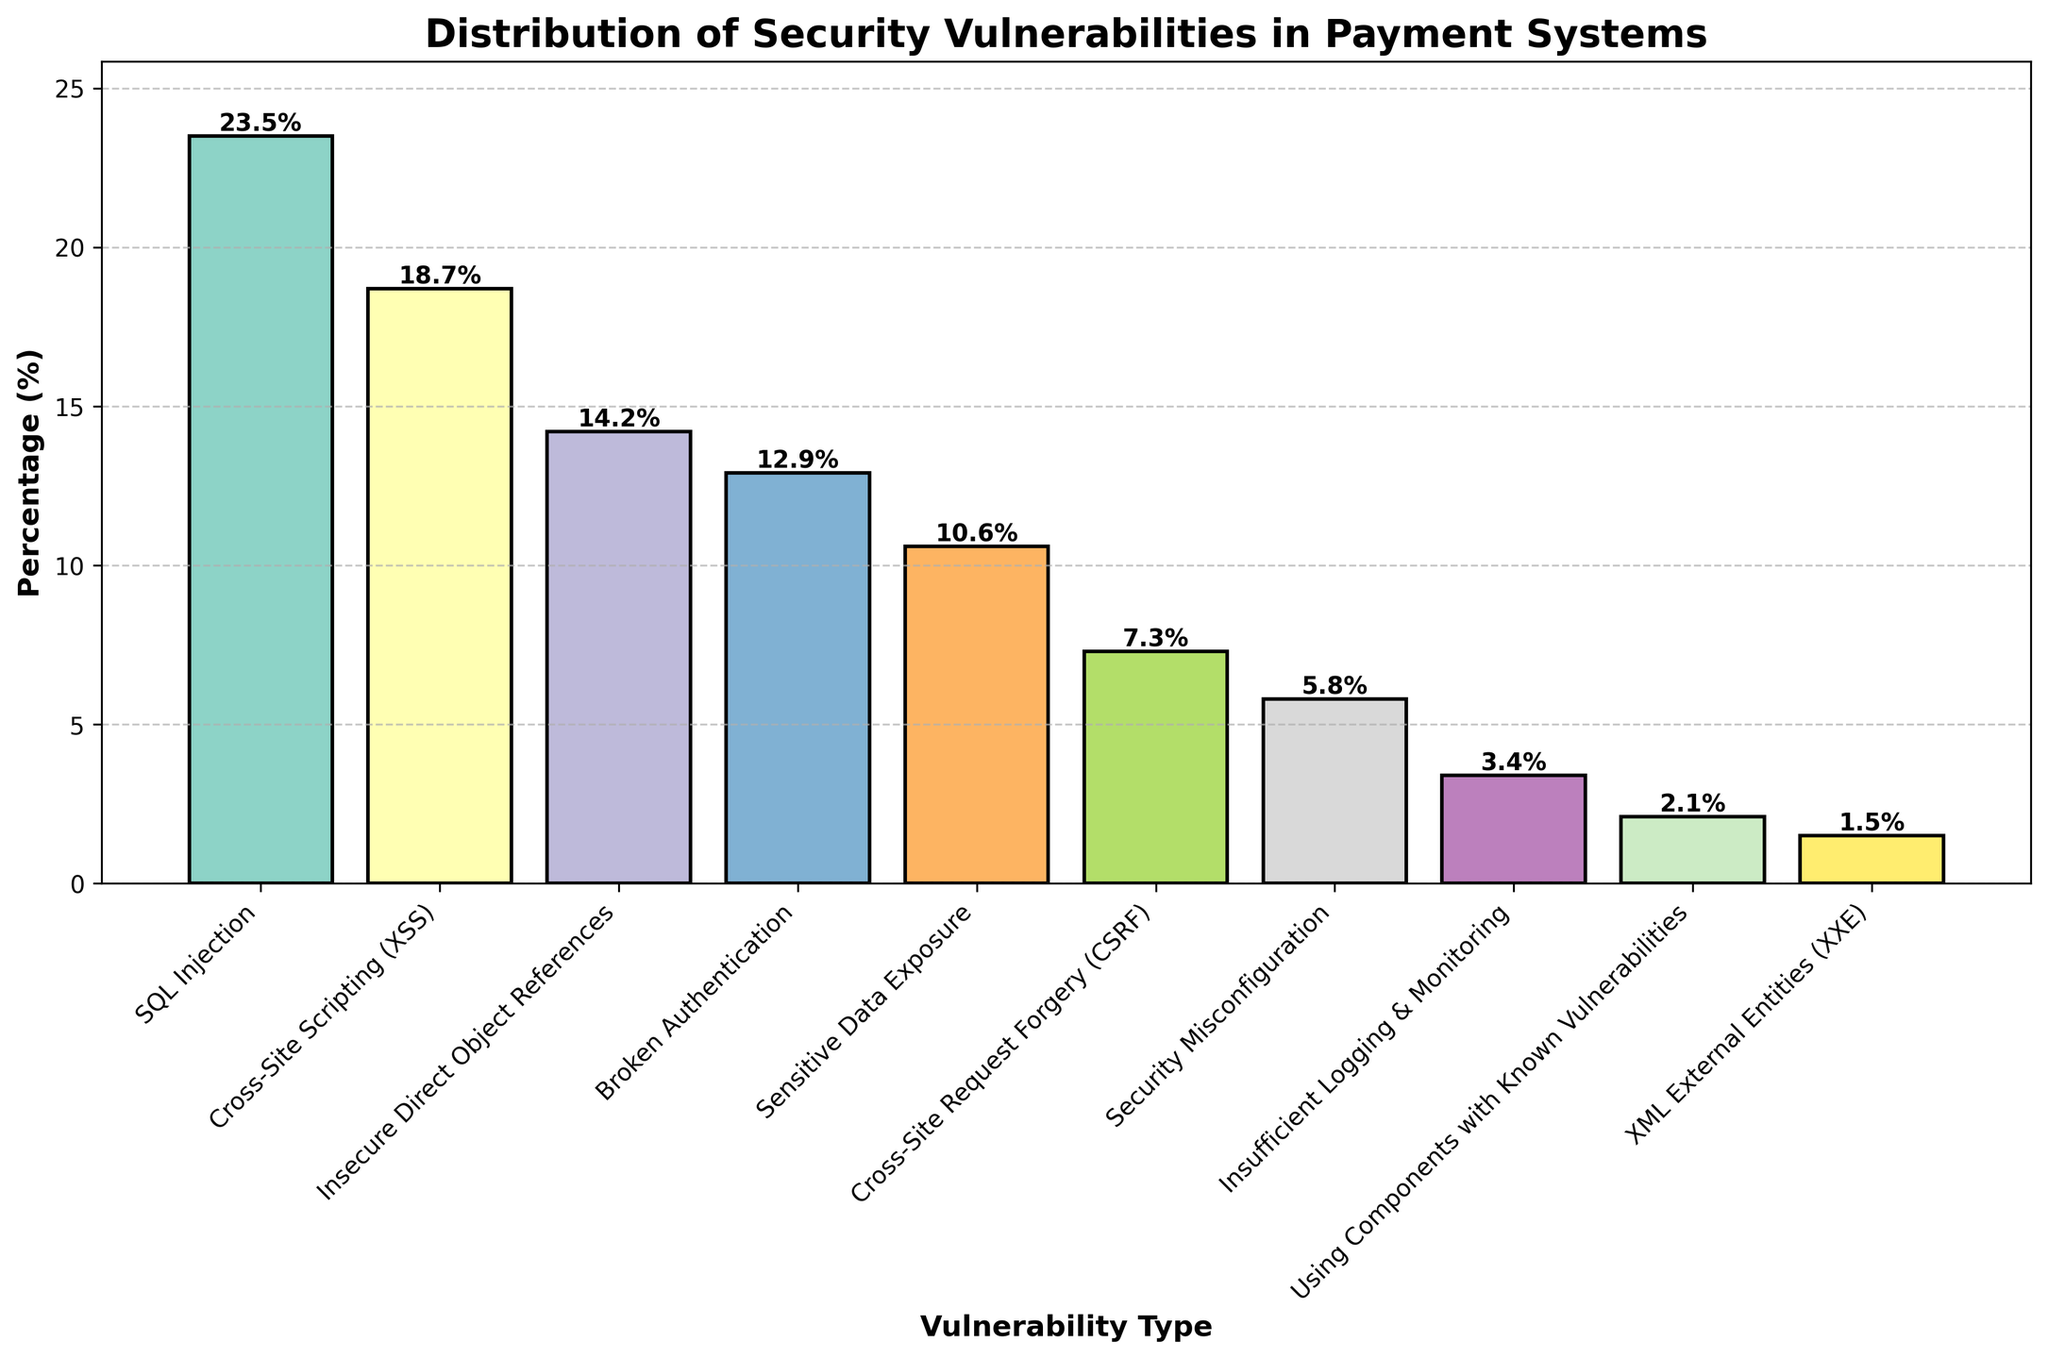Which type of security vulnerability is the most common in payment systems? The bar chart's title is "Distribution of Security Vulnerabilities in Payment Systems." The tallest bar represents SQL Injection, which has the highest percentage.
Answer: SQL Injection How does the percentage of Cross-Site Scripting (XSS) compare to Broken Authentication? Cross-Site Scripting (XSS) is at 18.7%, while Broken Authentication is at 12.9%. Comparing these two percentages directly, XSS is higher.
Answer: XSS is higher What is the combined percentage of Insecure Direct Object References and Sensitive Data Exposure? Insecure Direct Object References are 14.2%, and Sensitive Data Exposure is 10.6%. Adding these two percentages together: 14.2 + 10.6 = 24.8%.
Answer: 24.8% Does Cross-Site Request Forgery (CSRF) or Security Misconfiguration have a higher percentage? Cross-Site Request Forgery (CSRF) has a percentage of 7.3%, whereas Security Misconfiguration has a lower percentage of 5.8%.
Answer: CSRF is higher What's the difference in percentage between SQL Injection and Using Components with Known Vulnerabilities? SQL Injection is 23.5%, and Using Components with Known Vulnerabilities is 2.1%. Subtracting the two: 23.5 - 2.1 = 21.4%.
Answer: 21.4% What is the average percentage of all listed security vulnerabilities? Summing all the percentages: 23.5 + 18.7 + 14.2 + 12.9 + 10.6 + 7.3 + 5.8 + 3.4 + 2.1 + 1.5 = 100. The number of types is 10. So, the average is 100 / 10 = 10.0%.
Answer: 10.0% Among the listed types, which has the lowest percentage? By observing the shortest bar on the chart, XML External Entities (XXE) has the lowest percentage at 1.5%.
Answer: XML External Entities (XXE) What is the sum of the percentages for Cross-Site Scripting (XSS), Insecure Direct Object References, and Security Misconfiguration? XSS is 18.7%, Insecure Direct Object References is 14.2%, and Security Misconfiguration is 5.8%. Adding these together: 18.7 + 14.2 + 5.8 = 38.7%.
Answer: 38.7% Which has a higher combined percentage: Broken Authentication and Sensitive Data Exposure or Cross-Site Request Forgery (CSRF) and Security Misconfiguration? Broken Authentication is 12.9% and Sensitive Data Exposure is 10.6%, so their combined percentage is 12.9 + 10.6 = 23.5%. CSRF is 7.3% and Security Misconfiguration is 5.8%, so their combined percentage is 7.3 + 5.8 = 13.1%. Comparing 23.5% to 13.1%, Broken Authentication and Sensitive Data Exposure have a higher combined percentage.
Answer: Broken Authentication and Sensitive Data Exposure 